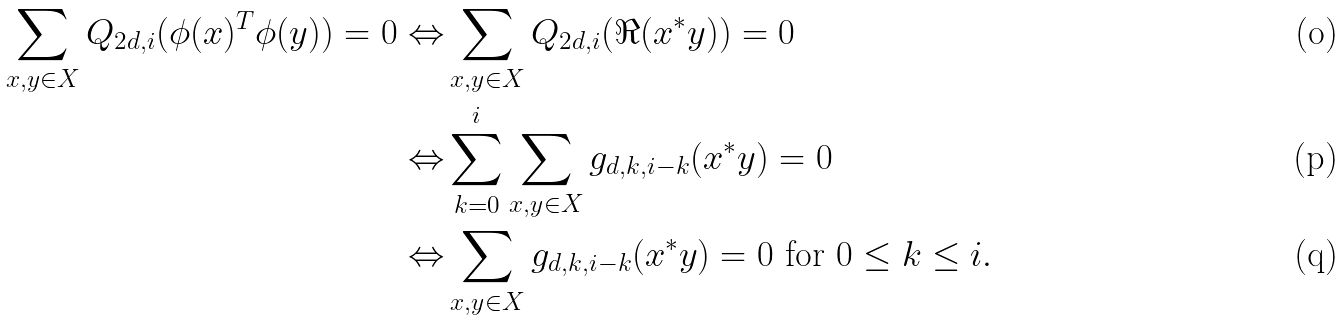<formula> <loc_0><loc_0><loc_500><loc_500>\sum _ { x , y \in X } Q _ { 2 d , i } ( \phi ( x ) ^ { T } \phi ( y ) ) = 0 \Leftrightarrow & \sum _ { x , y \in X } Q _ { 2 d , i } ( \Re ( x ^ { * } y ) ) = 0 \\ \Leftrightarrow & \sum _ { k = 0 } ^ { i } \sum _ { x , y \in X } g _ { d , k , i - k } ( x ^ { * } y ) = 0 \\ \Leftrightarrow & \sum _ { x , y \in X } g _ { d , k , i - k } ( x ^ { * } y ) = 0 \text { for } 0 \leq k \leq i .</formula> 